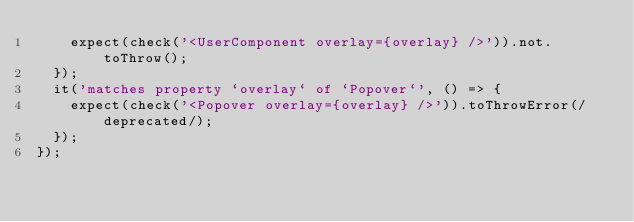Convert code to text. <code><loc_0><loc_0><loc_500><loc_500><_JavaScript_>    expect(check('<UserComponent overlay={overlay} />')).not.toThrow();
  });
  it('matches property `overlay` of `Popover`', () => {
    expect(check('<Popover overlay={overlay} />')).toThrowError(/deprecated/);
  });
});
</code> 